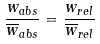<formula> <loc_0><loc_0><loc_500><loc_500>\frac { w _ { a b s } } { \overline { w } _ { a b s } } = \frac { w _ { r e l } } { \overline { w } _ { r e l } }</formula> 